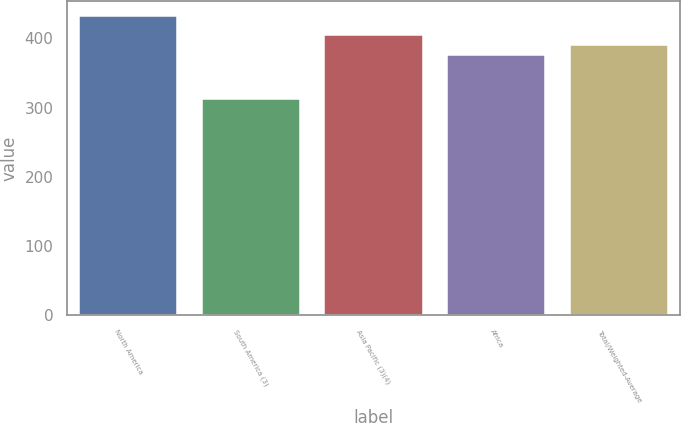<chart> <loc_0><loc_0><loc_500><loc_500><bar_chart><fcel>North America<fcel>South America (3)<fcel>Asia Pacific (3)(4)<fcel>Africa<fcel>Total/Weighted-Average<nl><fcel>432<fcel>313<fcel>405<fcel>376<fcel>390<nl></chart> 